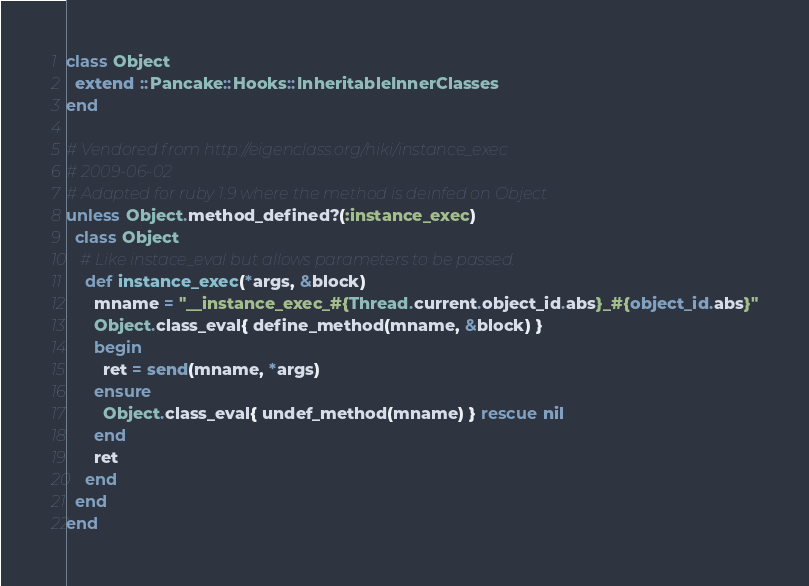<code> <loc_0><loc_0><loc_500><loc_500><_Ruby_>class Object
  extend ::Pancake::Hooks::InheritableInnerClasses
end

# Vendored from http://eigenclass.org/hiki/instance_exec
# 2009-06-02
# Adapted for ruby 1.9 where the method is deinfed on Object
unless Object.method_defined?(:instance_exec)
  class Object
   # Like instace_eval but allows parameters to be passed.
    def instance_exec(*args, &block)
      mname = "__instance_exec_#{Thread.current.object_id.abs}_#{object_id.abs}"
      Object.class_eval{ define_method(mname, &block) }
      begin
        ret = send(mname, *args)
      ensure
        Object.class_eval{ undef_method(mname) } rescue nil
      end
      ret
    end
  end
end
</code> 